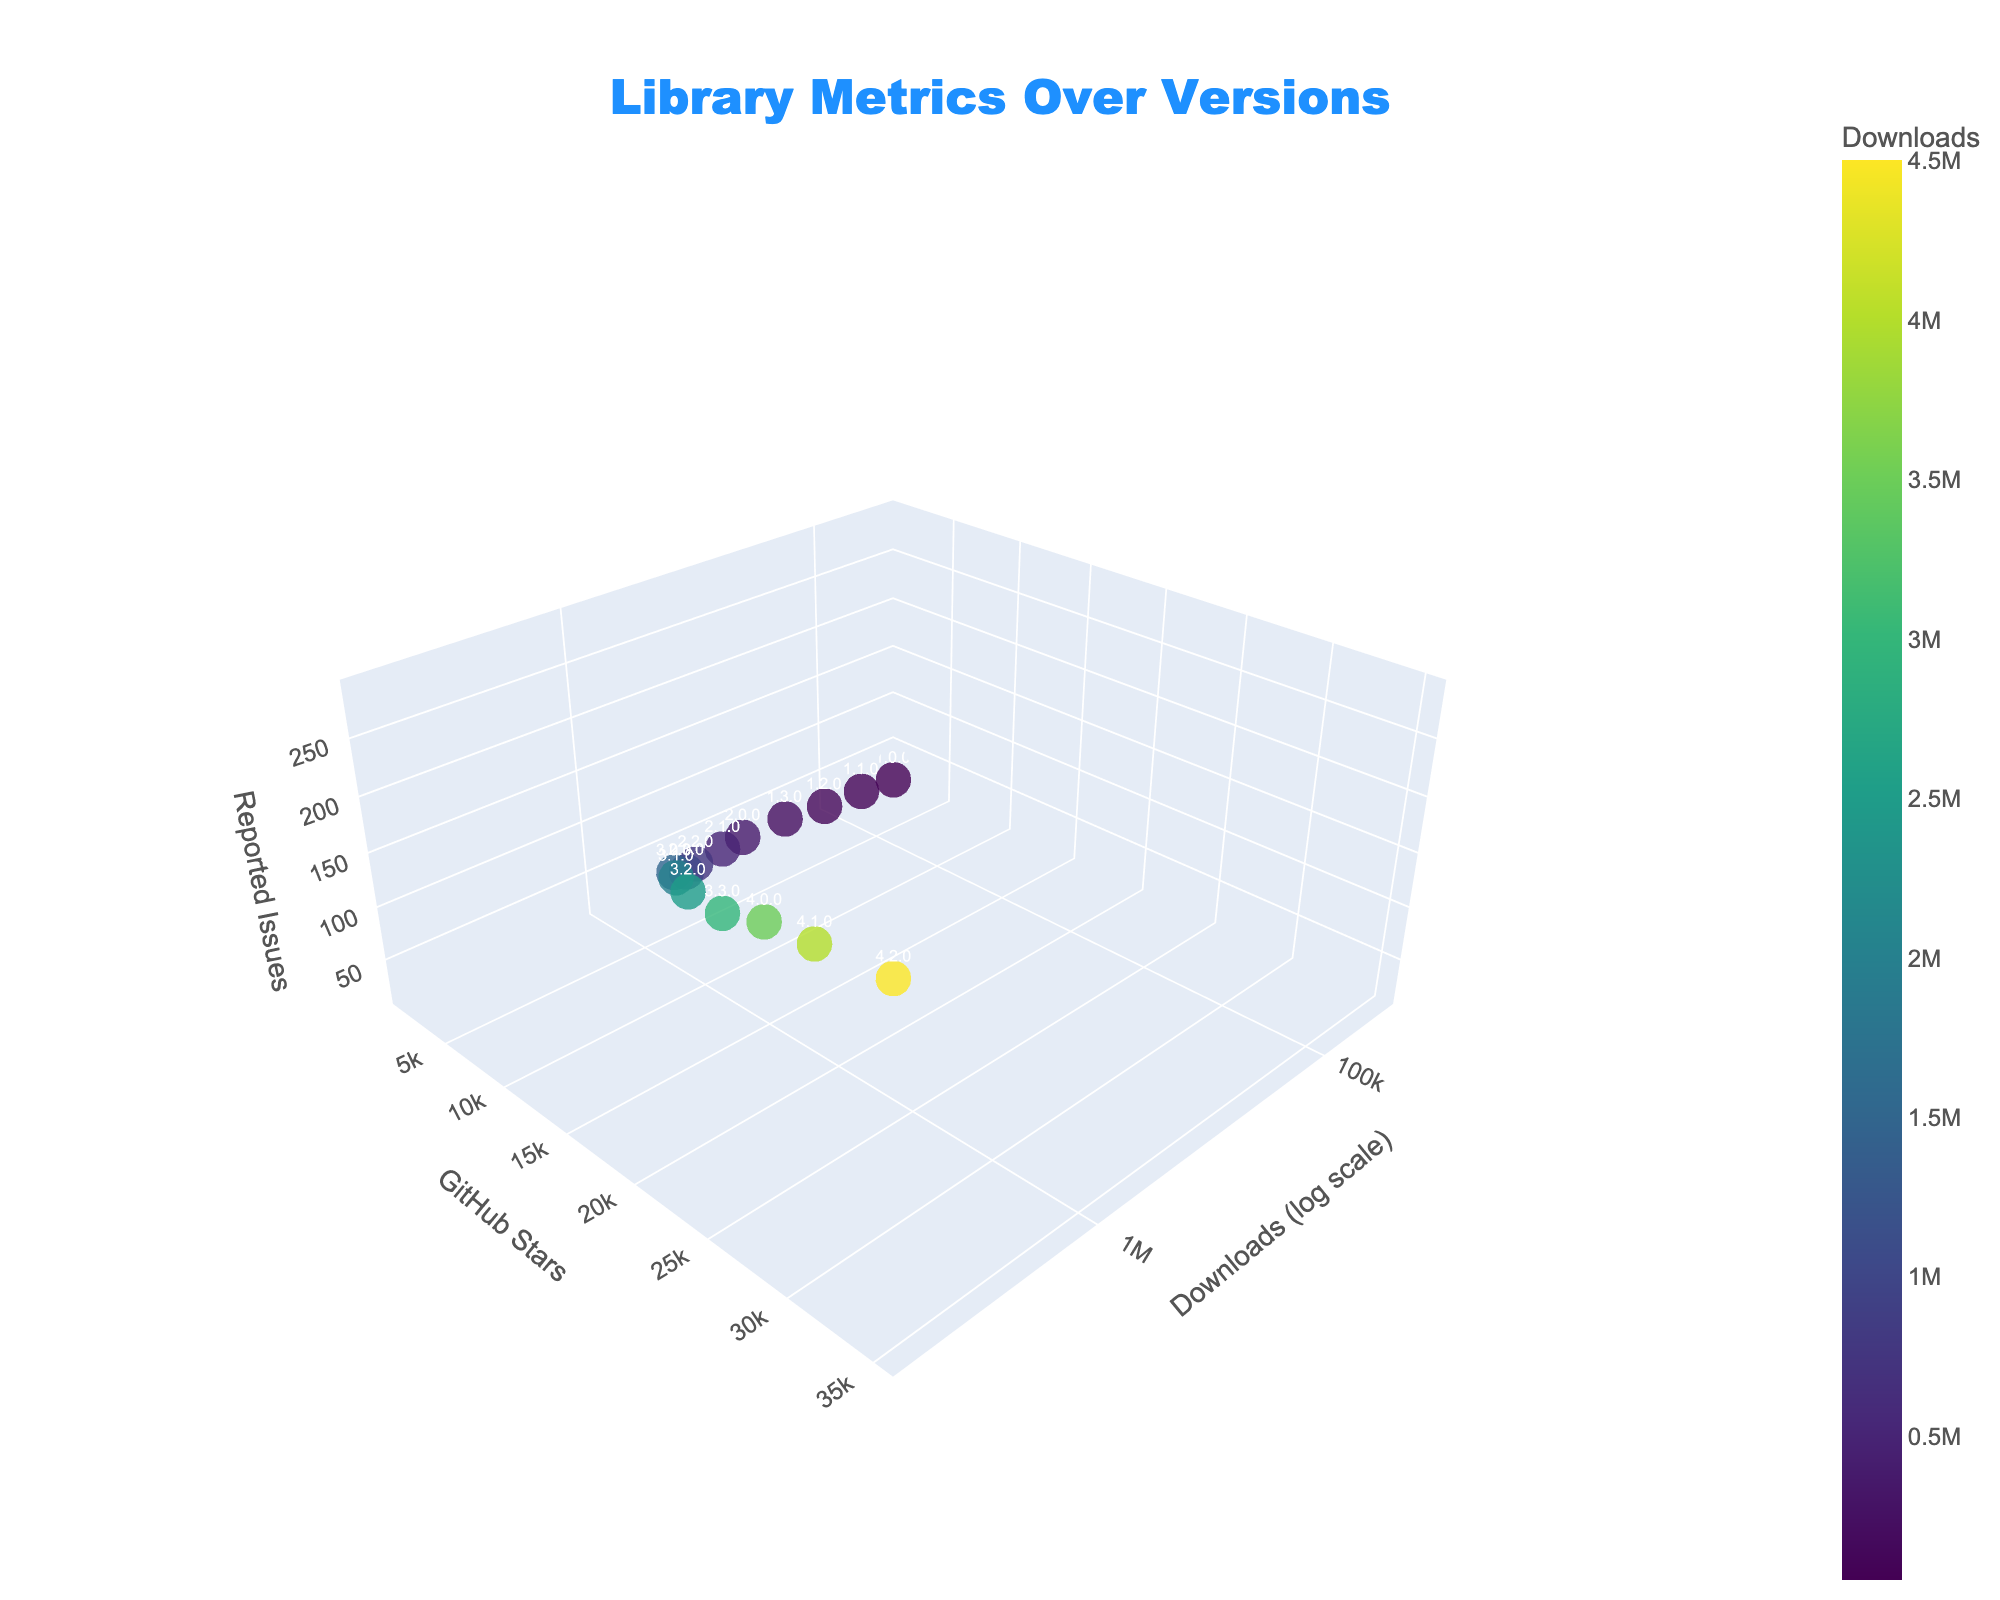What is the title of the figure? The title is usually displayed at the top of the figure. It reads "Library Metrics Over Versions".
Answer: Library Metrics Over Versions Which version has the highest number of downloads? The version with the highest number of downloads can be identified by the point with the highest x-coordinate value. This corresponds to version 4.2.0.
Answer: 4.2.0 How many data points are there in the figure? The number of data points can be counted from the figure, which corresponds to the number of different software versions. There are 15 versions listed in the provided data set.
Answer: 15 What's the x-axis title? The x-axis title is usually found along the direction of the x-axis. In this figure, it reads "Downloads (log scale)".
Answer: Downloads (log scale) Which version has the largest difference between GitHub stars and reported issues? To find this, identify the points with the maximum difference between the y-coordinate (GitHub stars) and the z-coordinate (reported issues). Version 4.2.0 has 35000 stars and 290 issues, the largest difference.
Answer: 4.2.0 What is the trend in reported issues as the number of downloads increases? Observing the z-coordinate (reported issues) as the x-coordinate (downloads) increases, we can see that the number of reported issues generally increases with the number of downloads.
Answer: Increases Of versions 2.0.0 and 3.0.0, which has more reported issues? Locate the corresponding points for versions 2.0.0 and 3.0.0 and compare their z-coordinates (reported issues). Version 3.0.0 has more reported issues (150 compared to 60 for version 2.0.0).
Answer: 3.0.0 What's the average number of GitHub stars for versions with more than 1,000,000 downloads? Identify the versions with more than 1,000,000 downloads (versions 3.0.0 to 4.2.0), sum their GitHub stars (12000 + 15000 + 18000 + 22000 + 26000 + 30000 + 35000), and divide by their count (7). Sum is 158,000, and the count is 7, so average = 158,000 / 7 = 22,571.43
Answer: 22,571.43 Which version has the highest density of issues relative to stars? Calculate the ratio of issues to stars for each version and compare. Version 1.0.0 has a ratio of 15/1200 = 0.0125, the highest among all versions.
Answer: 1.0.0 